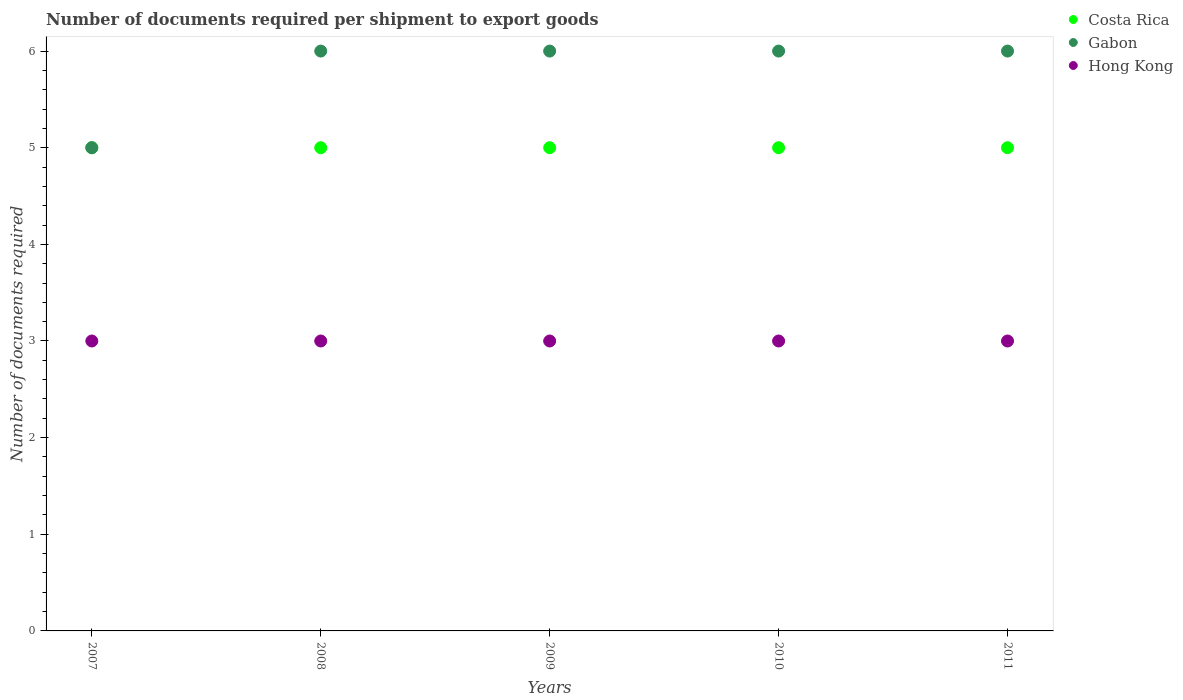What is the number of documents required per shipment to export goods in Costa Rica in 2008?
Offer a terse response. 5. Across all years, what is the maximum number of documents required per shipment to export goods in Costa Rica?
Offer a very short reply. 5. Across all years, what is the minimum number of documents required per shipment to export goods in Costa Rica?
Give a very brief answer. 5. In which year was the number of documents required per shipment to export goods in Hong Kong maximum?
Make the answer very short. 2007. What is the total number of documents required per shipment to export goods in Costa Rica in the graph?
Keep it short and to the point. 25. What is the difference between the number of documents required per shipment to export goods in Costa Rica in 2008 and that in 2010?
Ensure brevity in your answer.  0. What is the difference between the number of documents required per shipment to export goods in Costa Rica in 2009 and the number of documents required per shipment to export goods in Gabon in 2007?
Keep it short and to the point. 0. What is the average number of documents required per shipment to export goods in Hong Kong per year?
Your response must be concise. 3. In the year 2009, what is the difference between the number of documents required per shipment to export goods in Hong Kong and number of documents required per shipment to export goods in Costa Rica?
Your answer should be very brief. -2. In how many years, is the number of documents required per shipment to export goods in Gabon greater than 5.4?
Give a very brief answer. 4. Is the number of documents required per shipment to export goods in Hong Kong in 2008 less than that in 2010?
Offer a very short reply. No. What is the difference between the highest and the second highest number of documents required per shipment to export goods in Costa Rica?
Offer a terse response. 0. What is the difference between the highest and the lowest number of documents required per shipment to export goods in Hong Kong?
Your answer should be very brief. 0. In how many years, is the number of documents required per shipment to export goods in Costa Rica greater than the average number of documents required per shipment to export goods in Costa Rica taken over all years?
Ensure brevity in your answer.  0. Is the number of documents required per shipment to export goods in Gabon strictly greater than the number of documents required per shipment to export goods in Costa Rica over the years?
Ensure brevity in your answer.  No. How many years are there in the graph?
Offer a terse response. 5. What is the difference between two consecutive major ticks on the Y-axis?
Your answer should be very brief. 1. Does the graph contain grids?
Offer a terse response. No. Where does the legend appear in the graph?
Offer a very short reply. Top right. How many legend labels are there?
Your answer should be very brief. 3. How are the legend labels stacked?
Ensure brevity in your answer.  Vertical. What is the title of the graph?
Your answer should be compact. Number of documents required per shipment to export goods. Does "Panama" appear as one of the legend labels in the graph?
Offer a terse response. No. What is the label or title of the X-axis?
Provide a short and direct response. Years. What is the label or title of the Y-axis?
Give a very brief answer. Number of documents required. What is the Number of documents required in Gabon in 2007?
Keep it short and to the point. 5. What is the Number of documents required of Hong Kong in 2007?
Provide a short and direct response. 3. What is the Number of documents required of Costa Rica in 2009?
Keep it short and to the point. 5. What is the Number of documents required in Gabon in 2009?
Give a very brief answer. 6. What is the Number of documents required of Hong Kong in 2009?
Offer a very short reply. 3. What is the Number of documents required in Costa Rica in 2010?
Your answer should be very brief. 5. What is the Number of documents required of Gabon in 2011?
Your answer should be very brief. 6. What is the Number of documents required of Hong Kong in 2011?
Your response must be concise. 3. Across all years, what is the maximum Number of documents required in Costa Rica?
Offer a terse response. 5. Across all years, what is the maximum Number of documents required in Gabon?
Your answer should be very brief. 6. Across all years, what is the minimum Number of documents required of Hong Kong?
Your response must be concise. 3. What is the total Number of documents required in Hong Kong in the graph?
Provide a succinct answer. 15. What is the difference between the Number of documents required in Hong Kong in 2007 and that in 2008?
Your answer should be very brief. 0. What is the difference between the Number of documents required in Gabon in 2007 and that in 2009?
Your answer should be compact. -1. What is the difference between the Number of documents required of Gabon in 2007 and that in 2010?
Your answer should be very brief. -1. What is the difference between the Number of documents required of Hong Kong in 2007 and that in 2010?
Your answer should be very brief. 0. What is the difference between the Number of documents required of Costa Rica in 2007 and that in 2011?
Your answer should be very brief. 0. What is the difference between the Number of documents required in Gabon in 2007 and that in 2011?
Keep it short and to the point. -1. What is the difference between the Number of documents required in Hong Kong in 2007 and that in 2011?
Keep it short and to the point. 0. What is the difference between the Number of documents required of Gabon in 2008 and that in 2009?
Provide a succinct answer. 0. What is the difference between the Number of documents required of Costa Rica in 2008 and that in 2010?
Make the answer very short. 0. What is the difference between the Number of documents required of Hong Kong in 2008 and that in 2010?
Ensure brevity in your answer.  0. What is the difference between the Number of documents required in Costa Rica in 2008 and that in 2011?
Provide a succinct answer. 0. What is the difference between the Number of documents required of Gabon in 2008 and that in 2011?
Your answer should be very brief. 0. What is the difference between the Number of documents required in Gabon in 2009 and that in 2010?
Provide a short and direct response. 0. What is the difference between the Number of documents required in Hong Kong in 2009 and that in 2010?
Offer a terse response. 0. What is the difference between the Number of documents required of Costa Rica in 2009 and that in 2011?
Offer a very short reply. 0. What is the difference between the Number of documents required in Costa Rica in 2010 and that in 2011?
Ensure brevity in your answer.  0. What is the difference between the Number of documents required in Gabon in 2010 and that in 2011?
Provide a short and direct response. 0. What is the difference between the Number of documents required of Hong Kong in 2010 and that in 2011?
Provide a succinct answer. 0. What is the difference between the Number of documents required of Costa Rica in 2007 and the Number of documents required of Hong Kong in 2008?
Your response must be concise. 2. What is the difference between the Number of documents required of Costa Rica in 2007 and the Number of documents required of Hong Kong in 2009?
Provide a succinct answer. 2. What is the difference between the Number of documents required of Gabon in 2007 and the Number of documents required of Hong Kong in 2009?
Your answer should be very brief. 2. What is the difference between the Number of documents required in Costa Rica in 2007 and the Number of documents required in Gabon in 2010?
Make the answer very short. -1. What is the difference between the Number of documents required in Costa Rica in 2007 and the Number of documents required in Gabon in 2011?
Make the answer very short. -1. What is the difference between the Number of documents required in Costa Rica in 2008 and the Number of documents required in Gabon in 2009?
Your response must be concise. -1. What is the difference between the Number of documents required in Costa Rica in 2008 and the Number of documents required in Hong Kong in 2009?
Make the answer very short. 2. What is the difference between the Number of documents required in Gabon in 2008 and the Number of documents required in Hong Kong in 2009?
Your response must be concise. 3. What is the difference between the Number of documents required in Costa Rica in 2008 and the Number of documents required in Hong Kong in 2010?
Your response must be concise. 2. What is the difference between the Number of documents required of Gabon in 2008 and the Number of documents required of Hong Kong in 2010?
Provide a short and direct response. 3. What is the difference between the Number of documents required in Costa Rica in 2008 and the Number of documents required in Gabon in 2011?
Ensure brevity in your answer.  -1. What is the difference between the Number of documents required in Gabon in 2008 and the Number of documents required in Hong Kong in 2011?
Provide a succinct answer. 3. What is the difference between the Number of documents required of Costa Rica in 2009 and the Number of documents required of Gabon in 2011?
Your answer should be very brief. -1. What is the difference between the Number of documents required of Costa Rica in 2009 and the Number of documents required of Hong Kong in 2011?
Offer a terse response. 2. What is the difference between the Number of documents required of Gabon in 2009 and the Number of documents required of Hong Kong in 2011?
Your response must be concise. 3. What is the difference between the Number of documents required in Costa Rica in 2010 and the Number of documents required in Gabon in 2011?
Offer a very short reply. -1. What is the difference between the Number of documents required of Gabon in 2010 and the Number of documents required of Hong Kong in 2011?
Give a very brief answer. 3. In the year 2008, what is the difference between the Number of documents required of Costa Rica and Number of documents required of Gabon?
Offer a terse response. -1. In the year 2008, what is the difference between the Number of documents required of Costa Rica and Number of documents required of Hong Kong?
Your response must be concise. 2. In the year 2008, what is the difference between the Number of documents required of Gabon and Number of documents required of Hong Kong?
Make the answer very short. 3. In the year 2009, what is the difference between the Number of documents required of Costa Rica and Number of documents required of Hong Kong?
Provide a short and direct response. 2. In the year 2009, what is the difference between the Number of documents required of Gabon and Number of documents required of Hong Kong?
Your answer should be very brief. 3. In the year 2010, what is the difference between the Number of documents required of Costa Rica and Number of documents required of Gabon?
Ensure brevity in your answer.  -1. In the year 2010, what is the difference between the Number of documents required of Gabon and Number of documents required of Hong Kong?
Provide a succinct answer. 3. In the year 2011, what is the difference between the Number of documents required of Gabon and Number of documents required of Hong Kong?
Keep it short and to the point. 3. What is the ratio of the Number of documents required in Costa Rica in 2007 to that in 2008?
Give a very brief answer. 1. What is the ratio of the Number of documents required in Gabon in 2007 to that in 2008?
Give a very brief answer. 0.83. What is the ratio of the Number of documents required in Gabon in 2007 to that in 2009?
Provide a succinct answer. 0.83. What is the ratio of the Number of documents required in Costa Rica in 2007 to that in 2010?
Keep it short and to the point. 1. What is the ratio of the Number of documents required in Gabon in 2007 to that in 2010?
Your answer should be very brief. 0.83. What is the ratio of the Number of documents required of Hong Kong in 2007 to that in 2010?
Provide a short and direct response. 1. What is the ratio of the Number of documents required in Hong Kong in 2007 to that in 2011?
Your answer should be compact. 1. What is the ratio of the Number of documents required in Costa Rica in 2008 to that in 2009?
Keep it short and to the point. 1. What is the ratio of the Number of documents required of Gabon in 2008 to that in 2009?
Offer a terse response. 1. What is the ratio of the Number of documents required in Costa Rica in 2008 to that in 2010?
Your answer should be compact. 1. What is the ratio of the Number of documents required of Costa Rica in 2008 to that in 2011?
Keep it short and to the point. 1. What is the ratio of the Number of documents required of Costa Rica in 2009 to that in 2010?
Offer a very short reply. 1. What is the ratio of the Number of documents required of Costa Rica in 2009 to that in 2011?
Give a very brief answer. 1. What is the ratio of the Number of documents required in Gabon in 2009 to that in 2011?
Provide a short and direct response. 1. What is the ratio of the Number of documents required in Hong Kong in 2009 to that in 2011?
Your response must be concise. 1. What is the ratio of the Number of documents required of Gabon in 2010 to that in 2011?
Offer a terse response. 1. What is the difference between the highest and the second highest Number of documents required of Gabon?
Offer a very short reply. 0. What is the difference between the highest and the lowest Number of documents required of Costa Rica?
Offer a very short reply. 0. 